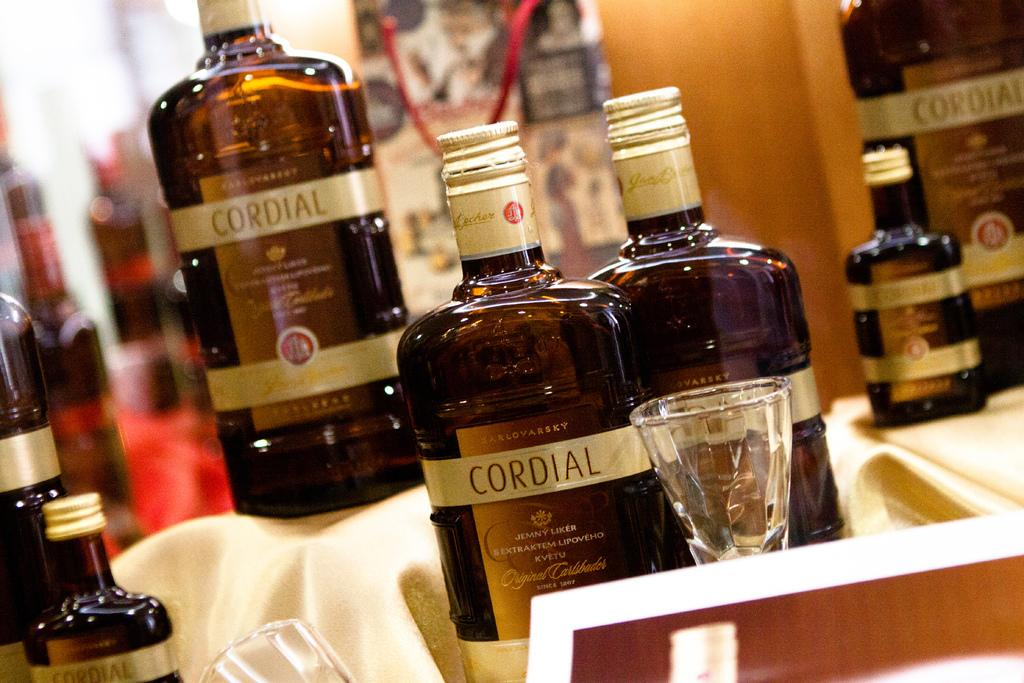<image>
Summarize the visual content of the image. A bottle has the brand name Cordial on it. 